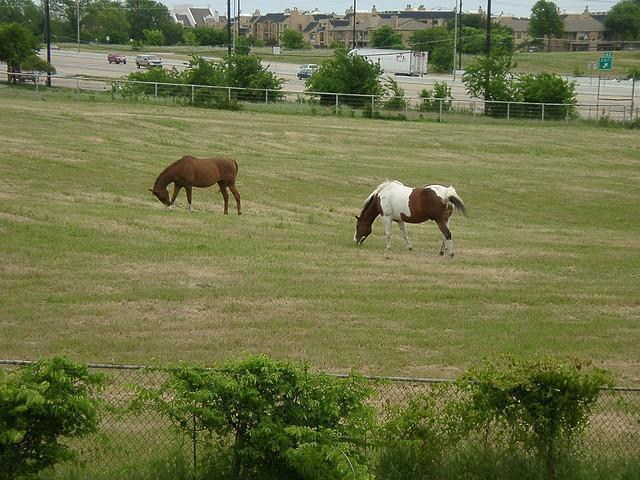What type of animals are present?
Select the accurate answer and provide explanation: 'Answer: answer
Rationale: rationale.'
Options: Deer, giraffe, dog, horse. Answer: horse.
Rationale: There are horses at the field. 